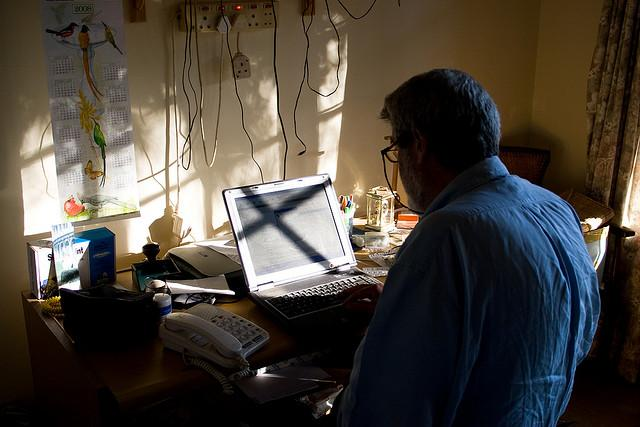What is the man using the computer to do?

Choices:
A) game
B) watch movie
C) film
D) type type 